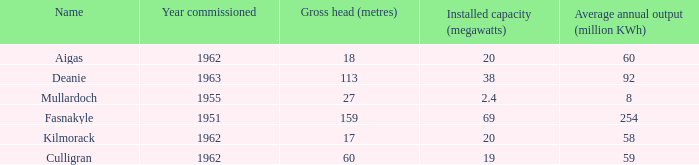What is the Year commissioned of the power station with a Gross head of 60 metres and Average annual output of less than 59 million KWh? None. 